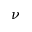<formula> <loc_0><loc_0><loc_500><loc_500>\nu</formula> 